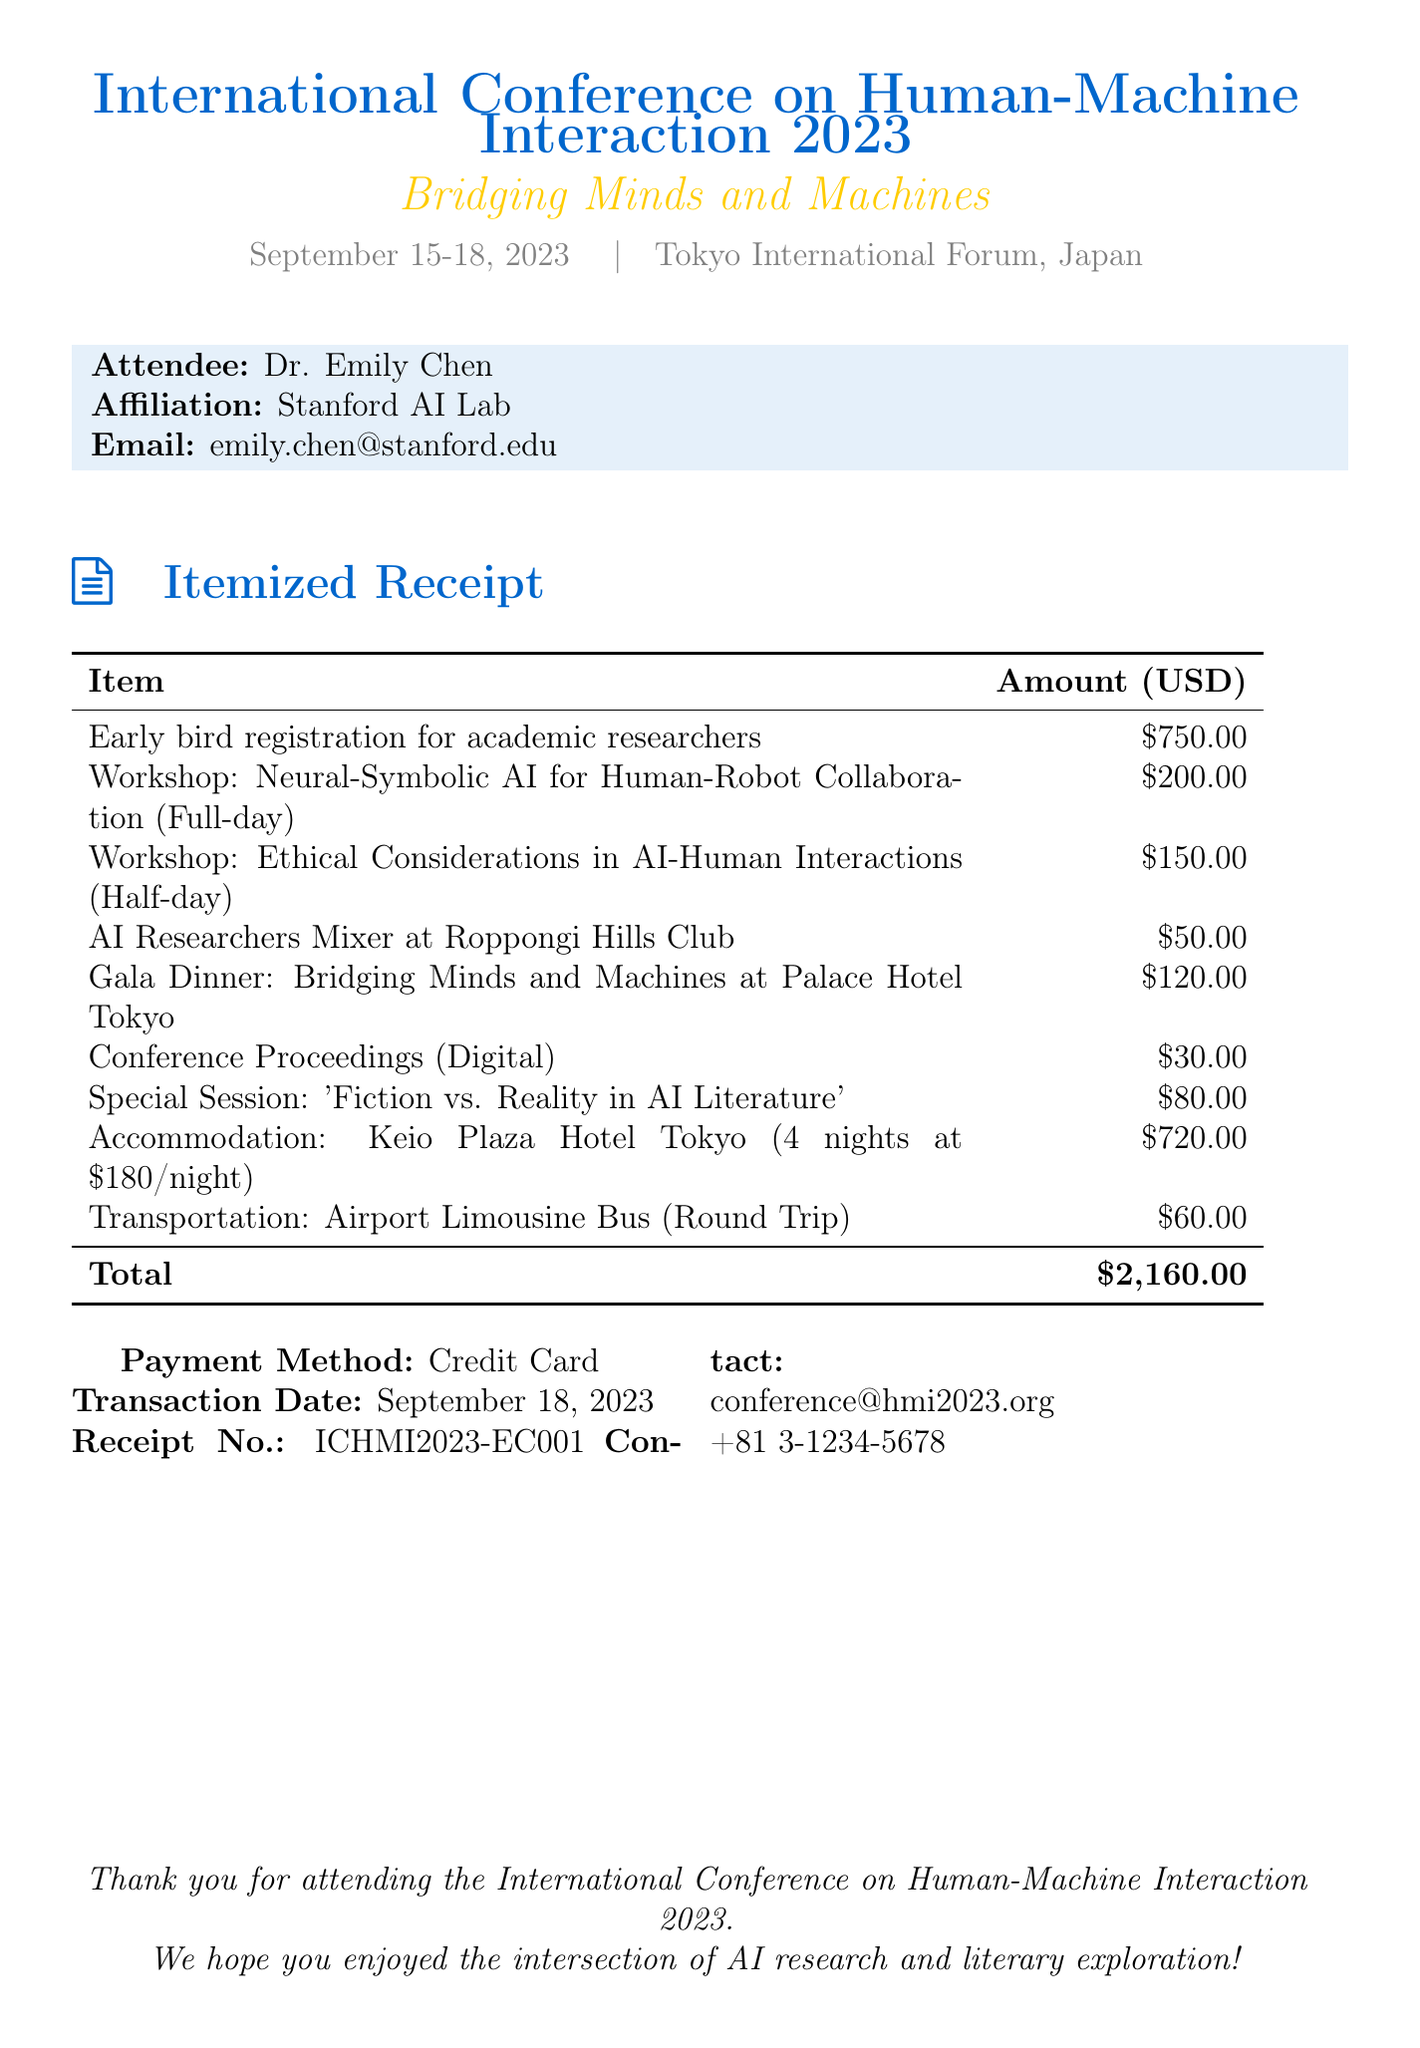What is the name of the conference? The name of the conference is provided in the document's heading.
Answer: International Conference on Human-Machine Interaction 2023 What is the venue of the conference? The venue is mentioned directly in the document following the conference name.
Answer: Tokyo International Forum, Tokyo, Japan Who is the attendee? The attendee's name is stated in the section with the attendee information.
Answer: Dr. Emily Chen How much is the early bird registration fee? The early bird registration fee is noted in the itemized receipt section.
Answer: $750.00 What are the total accommodation fees? The total accommodation fees are calculated from the rate per night and the number of nights stated in the document.
Answer: $720.00 What is the fee for the AI Researchers Mixer? The fee for the AI Researchers Mixer is listed in the networking events section of the invoice.
Answer: $50.00 How many nights did Dr. Emily Chen stay at the hotel? The number of nights is mentioned with the accommodation information.
Answer: 4 What is the total amount due? The total amount is calculated and summarized at the end of the itemized receipt section.
Answer: $2,160.00 What payment method was used? The payment method is stated in the document under the payment details section.
Answer: Credit Card 